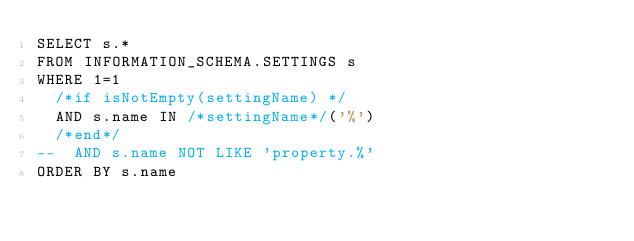<code> <loc_0><loc_0><loc_500><loc_500><_SQL_>SELECT s.*
FROM INFORMATION_SCHEMA.SETTINGS s
WHERE 1=1
  /*if isNotEmpty(settingName) */
  AND s.name IN /*settingName*/('%')
  /*end*/
--  AND s.name NOT LIKE 'property.%'
ORDER BY s.name</code> 